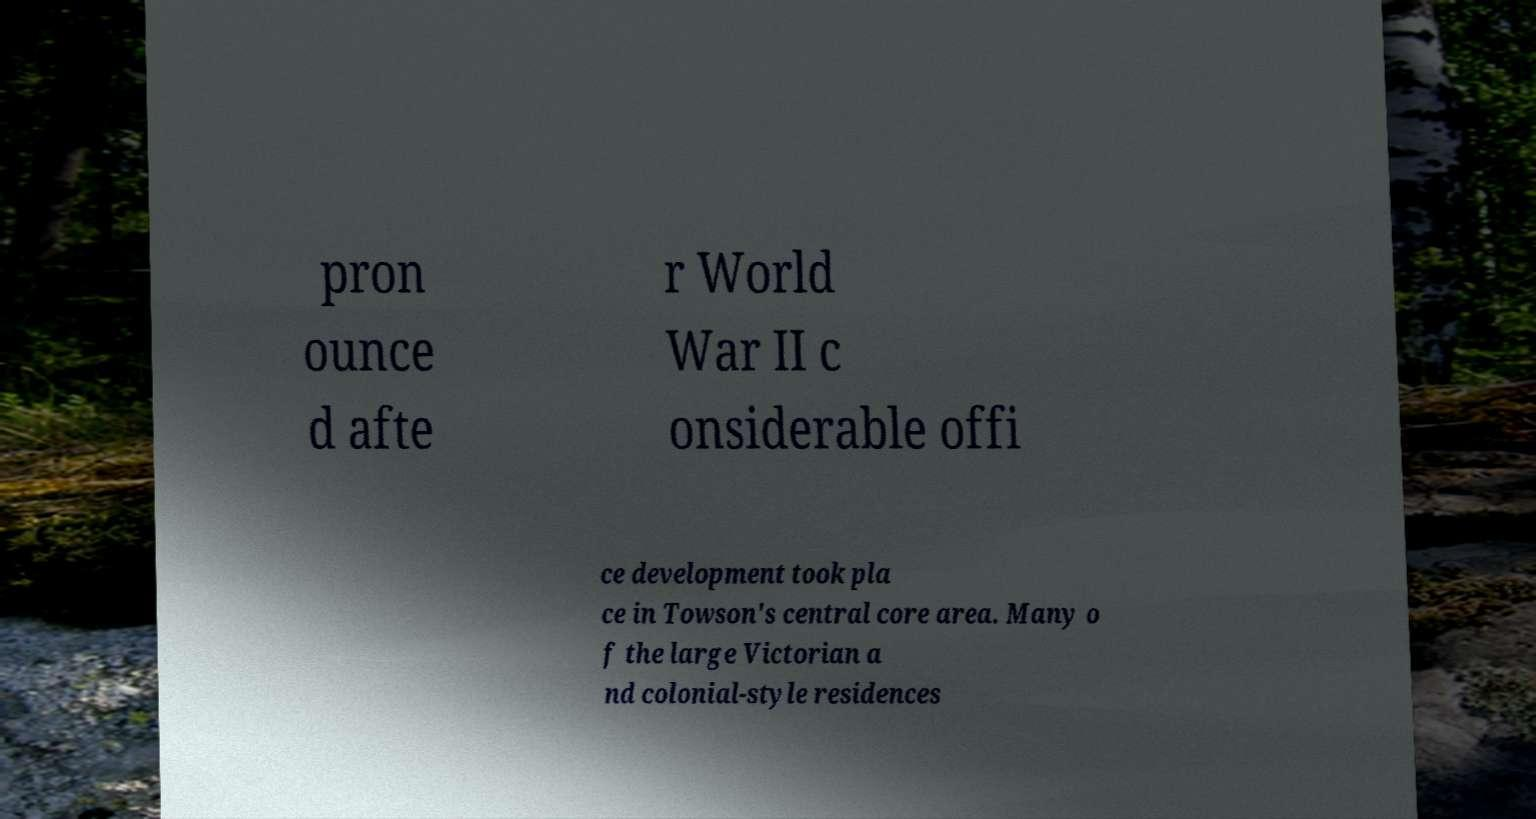For documentation purposes, I need the text within this image transcribed. Could you provide that? pron ounce d afte r World War II c onsiderable offi ce development took pla ce in Towson's central core area. Many o f the large Victorian a nd colonial-style residences 